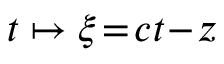Convert formula to latex. <formula><loc_0><loc_0><loc_500><loc_500>t \mapsto \xi \, = \, c t \, - \, z</formula> 